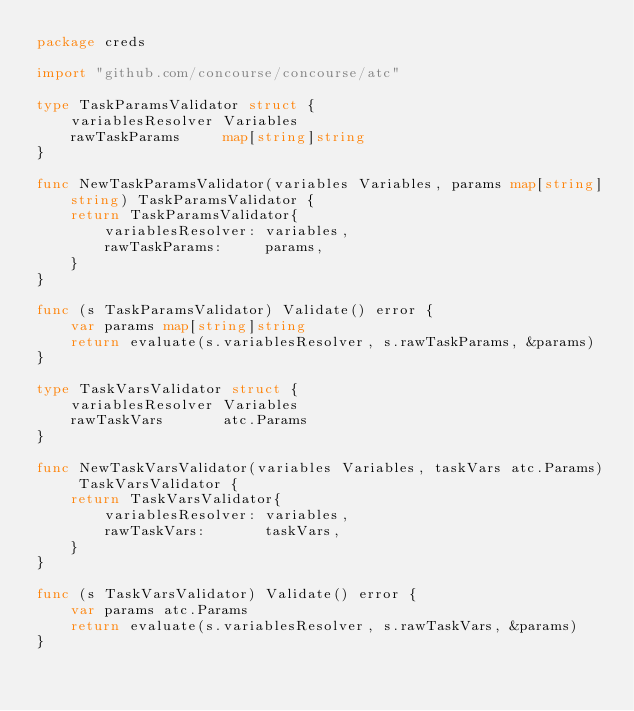Convert code to text. <code><loc_0><loc_0><loc_500><loc_500><_Go_>package creds

import "github.com/concourse/concourse/atc"

type TaskParamsValidator struct {
	variablesResolver Variables
	rawTaskParams     map[string]string
}

func NewTaskParamsValidator(variables Variables, params map[string]string) TaskParamsValidator {
	return TaskParamsValidator{
		variablesResolver: variables,
		rawTaskParams:     params,
	}
}

func (s TaskParamsValidator) Validate() error {
	var params map[string]string
	return evaluate(s.variablesResolver, s.rawTaskParams, &params)
}

type TaskVarsValidator struct {
	variablesResolver Variables
	rawTaskVars       atc.Params
}

func NewTaskVarsValidator(variables Variables, taskVars atc.Params) TaskVarsValidator {
	return TaskVarsValidator{
		variablesResolver: variables,
		rawTaskVars:       taskVars,
	}
}

func (s TaskVarsValidator) Validate() error {
	var params atc.Params
	return evaluate(s.variablesResolver, s.rawTaskVars, &params)
}
</code> 